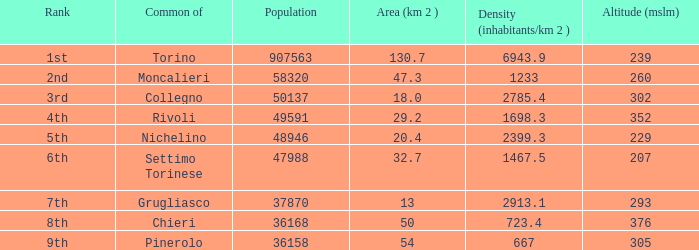What is the name of the 9th ranked common? Pinerolo. 